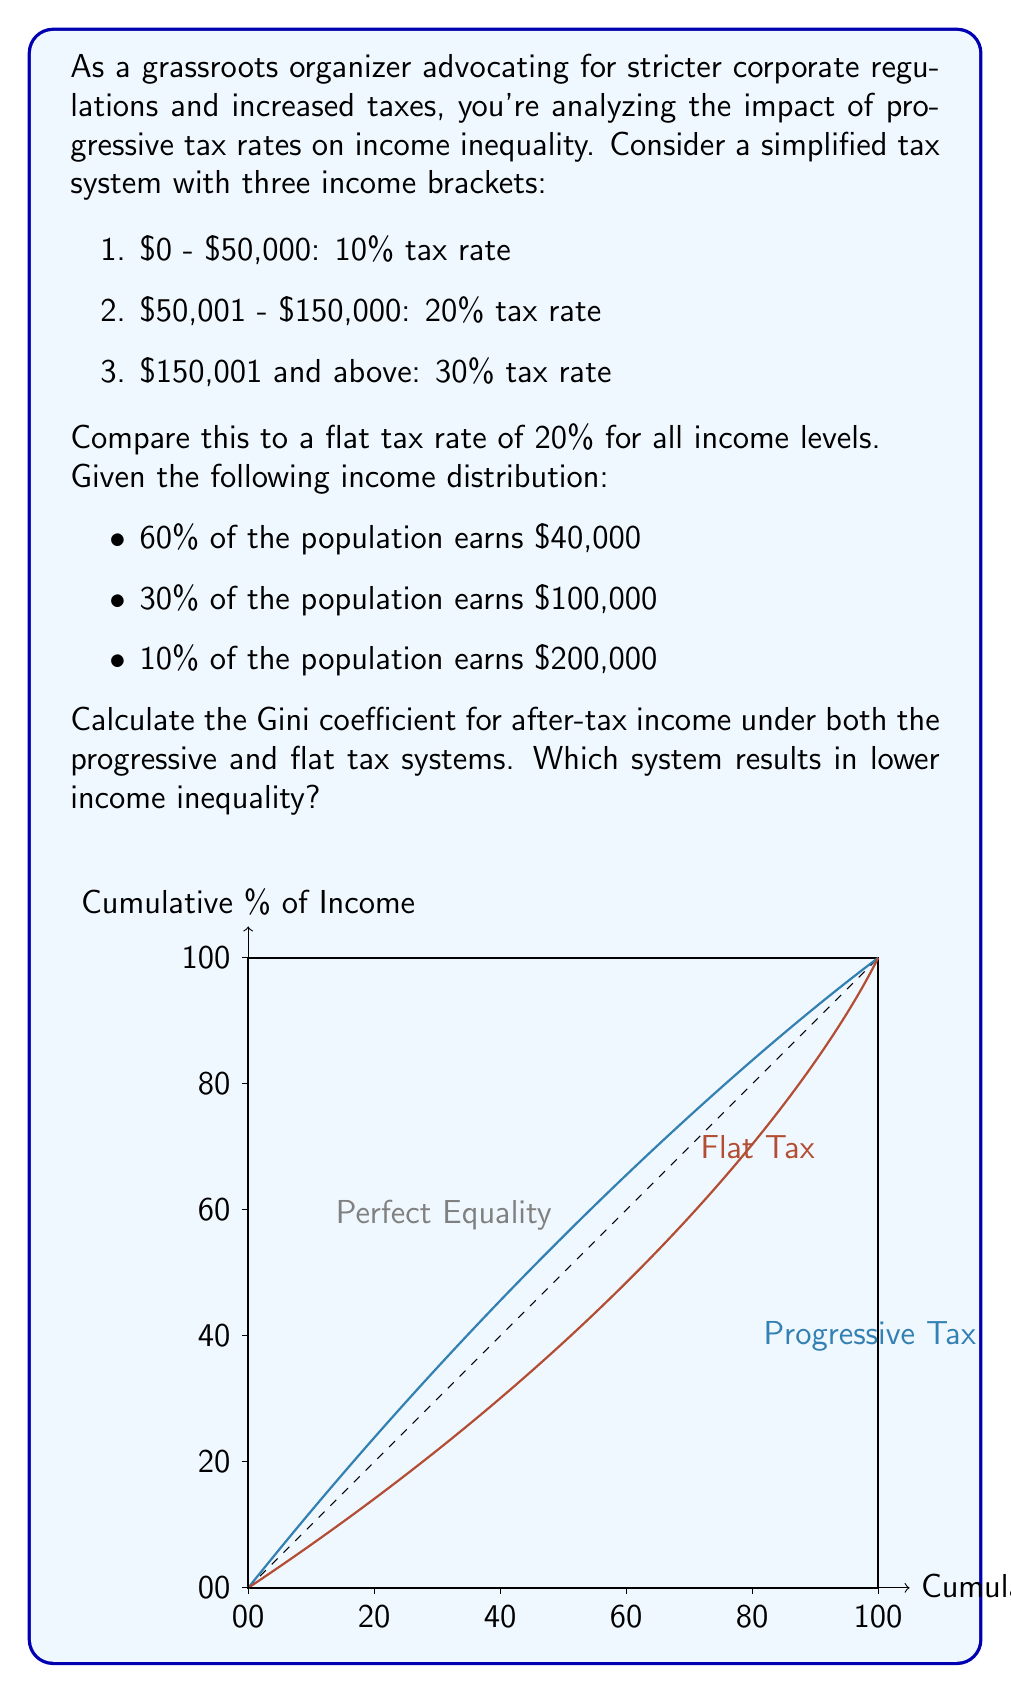Can you solve this math problem? To solve this problem, we need to calculate the Gini coefficient for both tax systems. The Gini coefficient is a measure of income inequality, where 0 represents perfect equality and 1 represents perfect inequality.

Step 1: Calculate after-tax incomes for each group under both systems.

Progressive Tax System:
1. $40,000 income: $40,000 * 0.10 = $4,000 tax; After-tax income = $36,000
2. $100,000 income: $50,000 * 0.10 + $50,000 * 0.20 = $15,000 tax; After-tax income = $85,000
3. $200,000 income: $50,000 * 0.10 + $100,000 * 0.20 + $50,000 * 0.30 = $40,000 tax; After-tax income = $160,000

Flat Tax System (20% for all):
1. $40,000 income: $40,000 * 0.20 = $8,000 tax; After-tax income = $32,000
2. $100,000 income: $100,000 * 0.20 = $20,000 tax; After-tax income = $80,000
3. $200,000 income: $200,000 * 0.20 = $40,000 tax; After-tax income = $160,000

Step 2: Calculate the Gini coefficient for each system.

The formula for the Gini coefficient is:

$$ G = \frac{\sum_{i=1}^{n} \sum_{j=1}^{n} |x_i - x_j|}{2n^2\bar{x}} $$

Where $x_i$ and $x_j$ are individual incomes, $n$ is the number of individuals, and $\bar{x}$ is the mean income.

For the progressive tax system:
Mean income = $(36,000 * 0.60 + 85,000 * 0.30 + 160,000 * 0.10) = $59,900$

$G_{progressive} = \frac{0.60 * 0.30 * |36,000 - 85,000| + 0.60 * 0.10 * |36,000 - 160,000| + 0.30 * 0.10 * |85,000 - 160,000|}{2 * 59,900} = 0.2868$

For the flat tax system:
Mean income = $(32,000 * 0.60 + 80,000 * 0.30 + 160,000 * 0.10) = $56,800$

$G_{flat} = \frac{0.60 * 0.30 * |32,000 - 80,000| + 0.60 * 0.10 * |32,000 - 160,000| + 0.30 * 0.10 * |80,000 - 160,000|}{2 * 56,800} = 0.3204$

Step 3: Compare the Gini coefficients.

The progressive tax system results in a lower Gini coefficient (0.2868) compared to the flat tax system (0.3204), indicating lower income inequality.
Answer: Progressive tax system: Gini = 0.2868
Flat tax system: Gini = 0.3204
Progressive tax system results in lower income inequality. 